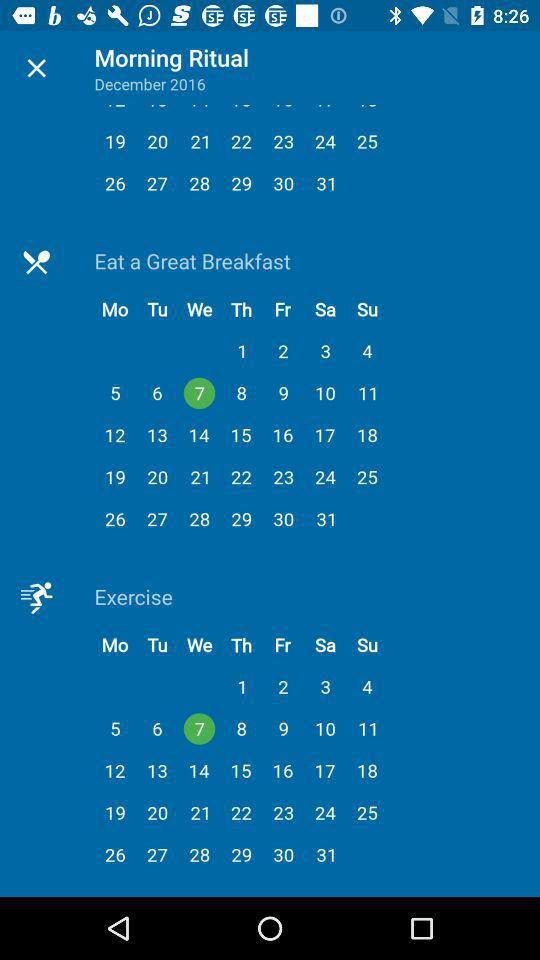What month is it? It is the month of December 2016. 